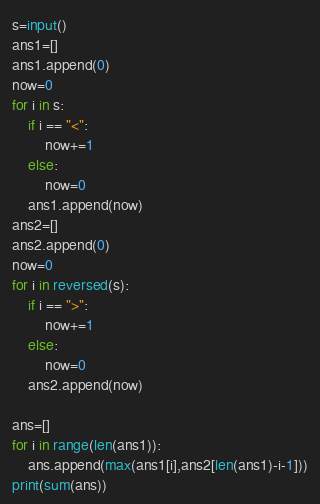<code> <loc_0><loc_0><loc_500><loc_500><_Python_>s=input()
ans1=[]
ans1.append(0)
now=0
for i in s:
    if i == "<":
        now+=1
    else:
        now=0
    ans1.append(now)
ans2=[]
ans2.append(0)
now=0
for i in reversed(s):
    if i == ">":
        now+=1
    else:
        now=0
    ans2.append(now)

ans=[]
for i in range(len(ans1)):
    ans.append(max(ans1[i],ans2[len(ans1)-i-1]))
print(sum(ans))</code> 